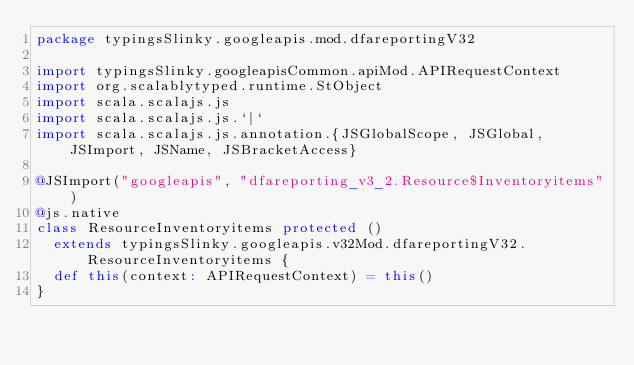Convert code to text. <code><loc_0><loc_0><loc_500><loc_500><_Scala_>package typingsSlinky.googleapis.mod.dfareportingV32

import typingsSlinky.googleapisCommon.apiMod.APIRequestContext
import org.scalablytyped.runtime.StObject
import scala.scalajs.js
import scala.scalajs.js.`|`
import scala.scalajs.js.annotation.{JSGlobalScope, JSGlobal, JSImport, JSName, JSBracketAccess}

@JSImport("googleapis", "dfareporting_v3_2.Resource$Inventoryitems")
@js.native
class ResourceInventoryitems protected ()
  extends typingsSlinky.googleapis.v32Mod.dfareportingV32.ResourceInventoryitems {
  def this(context: APIRequestContext) = this()
}
</code> 